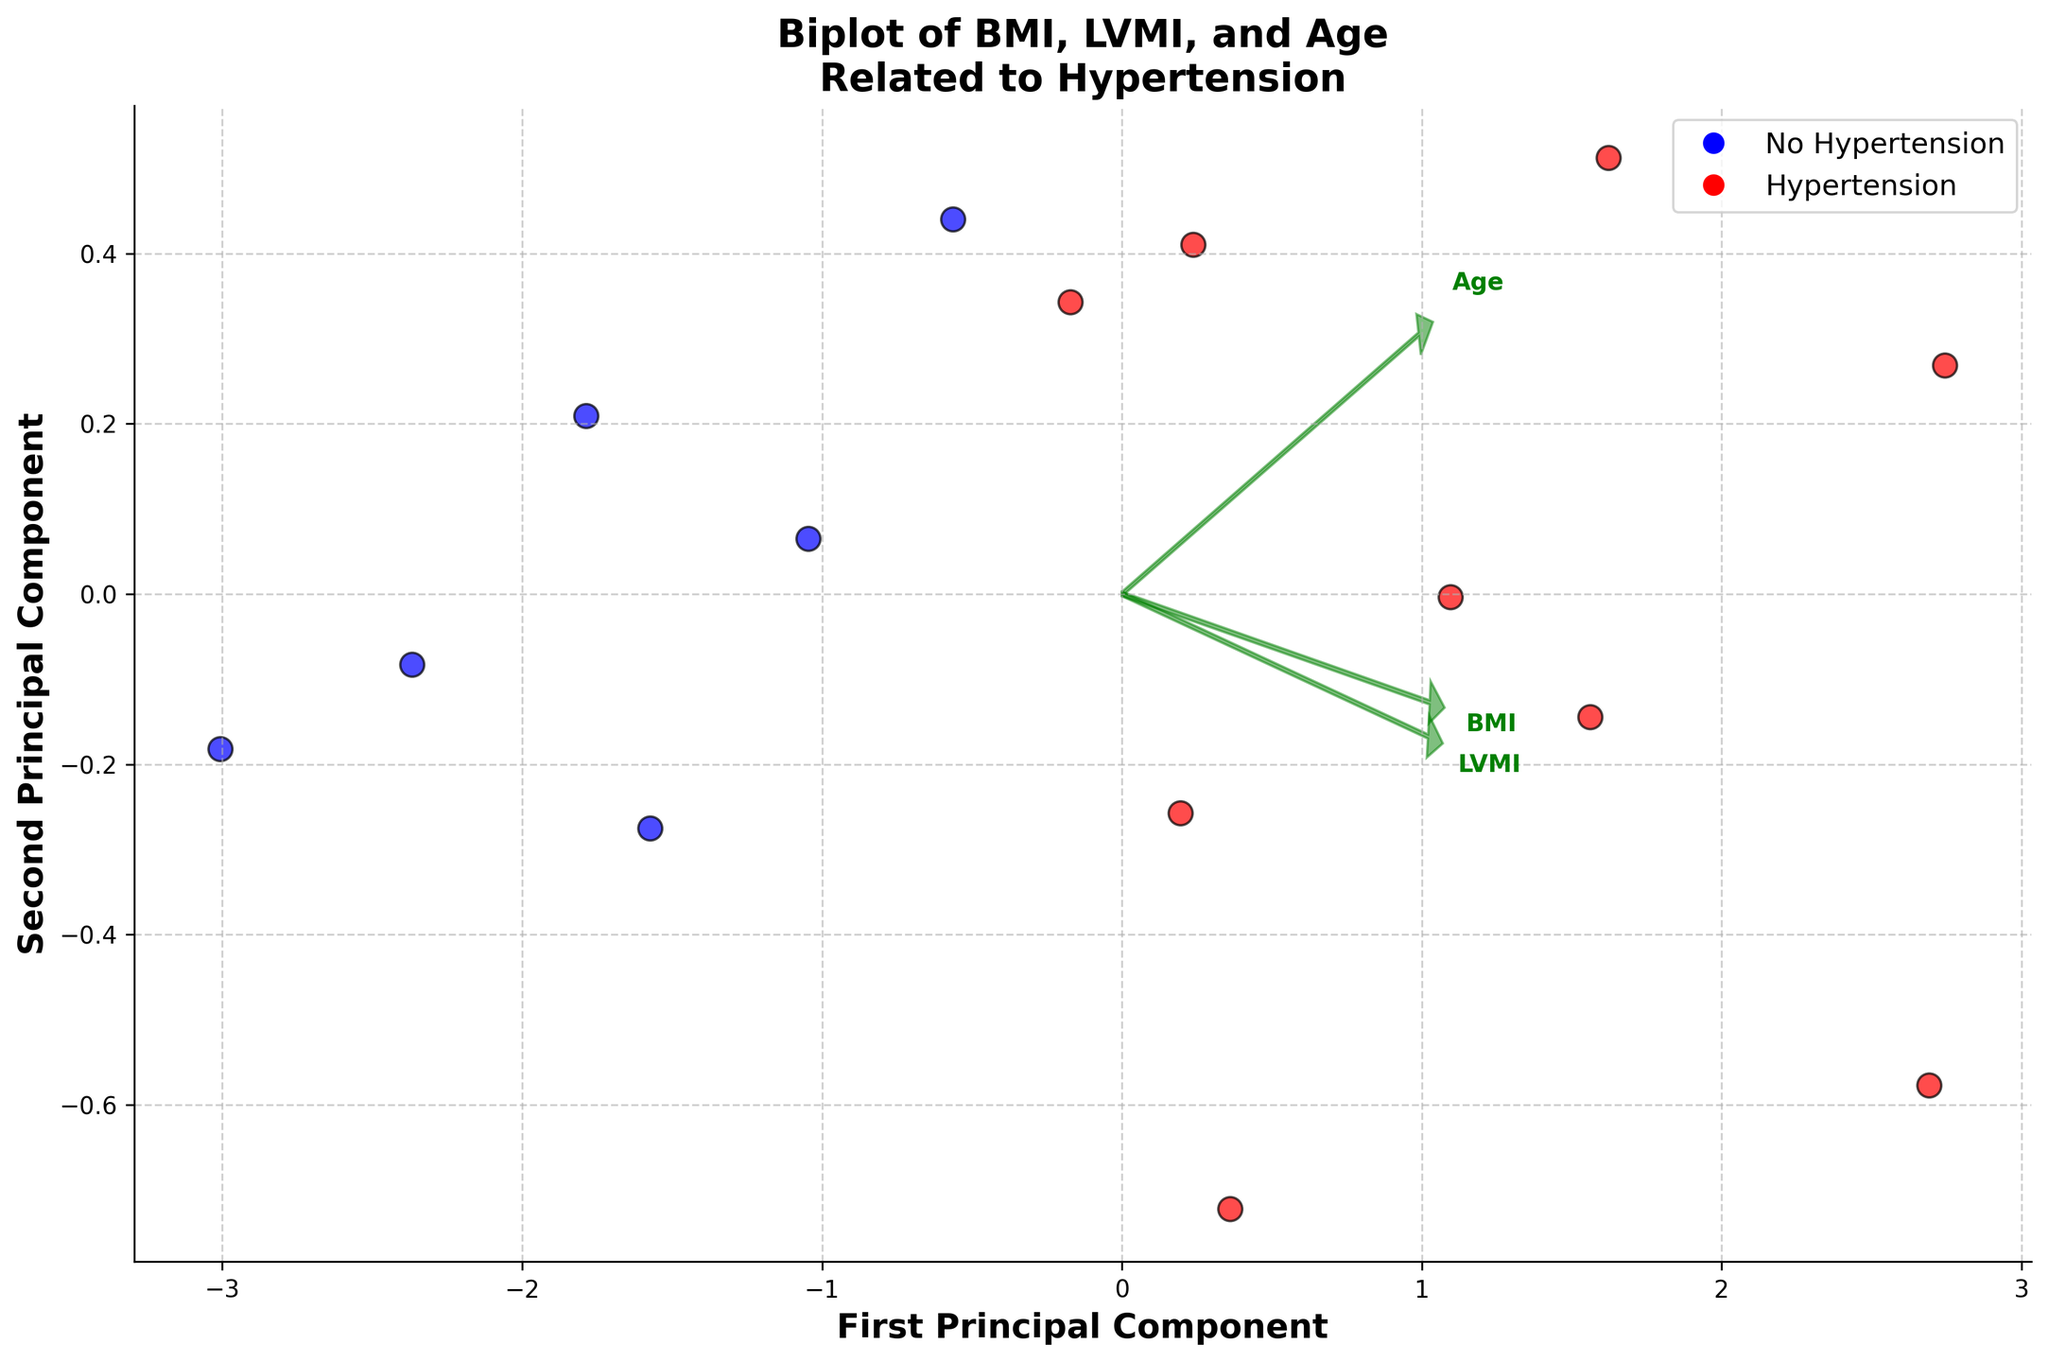What does the title of the biplot indicate? The title of the biplot provides an overview of the relationship being studied. It states that the plot depicts the relationship between body mass index (BMI) and left ventricular mass index (LVMI) in patients with and without hypertension.
Answer: Relationship between BMI and LVMI in patients with and without hypertension How many principal components are shown in the biplot? The biplot indicates two principal components. These are represented by the x-axis labeled as "First Principal Component" and the y-axis labeled as "Second Principal Component."
Answer: Two What colors are used to distinguish between patients with and without hypertension? The biplot uses red to represent patients with hypertension and blue to represent patients without hypertension.
Answer: Red and Blue Which feature vectors are shown in the biplot? The feature vectors shown are BMI, LVMI, and Age. These are represented by arrows starting at the origin, pointing in various directions on the plot.
Answer: BMI, LVMI, and Age Do patients without hypertension tend to cluster in a different area compared to those with hypertension? By observing the scatter plot, it can be seen that the blue points (patients without hypertension) tend to cluster separately from the red points (patients with hypertension).
Answer: Yes Which principal component axis explains more variance in the data? The principal components' contributions can be inferred from the positioning of the data points along the axes. The first principal component axis typically explains more variance, which is seen by the broader spread of points along this axis compared to the second.
Answer: First Principal Component From the feature vectors, which variable seems to have the strongest correlation with the first principal component? The length and direction of the arrows help us determine this. LVMI has the longest arrow among the feature vectors along the first principal component, indicating a strong correlation with the first principal component.
Answer: LVMI Is there any significant overlap between the groups of patients with and without hypertension? The scatter plot shows some degree of separation between red and blue points, but there is also some overlap indicating that while there are distinct clusters, some patients' data points mix between hypertensive and non-hypertensive ranges.
Answer: Yes, there is some overlap Are patients with higher BMI more likely to have hypertension based on this plot? The plot shows the principal component representation but does not explicitly confirm the relationship between BMI and hypertension directly. However, by observing the direction of the BMI vector and the clustering of red points (patients with hypertension), it can be inferred that higher BMI tends to associate with hypertension.
Answer: Yes In which direction does the Age vector point relative to the principal components? The Age vector points in a direction that has a mix of contributions from both principal components, not completely aligned with either the first or second principal component axes. This suggests Age is spread out and has some correlation with both.
Answer: Between the First and Second Principal Component 